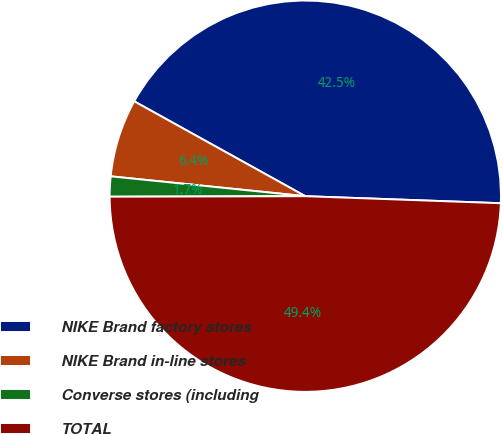Convert chart. <chart><loc_0><loc_0><loc_500><loc_500><pie_chart><fcel>NIKE Brand factory stores<fcel>NIKE Brand in-line stores<fcel>Converse stores (including<fcel>TOTAL<nl><fcel>42.52%<fcel>6.44%<fcel>1.66%<fcel>49.39%<nl></chart> 